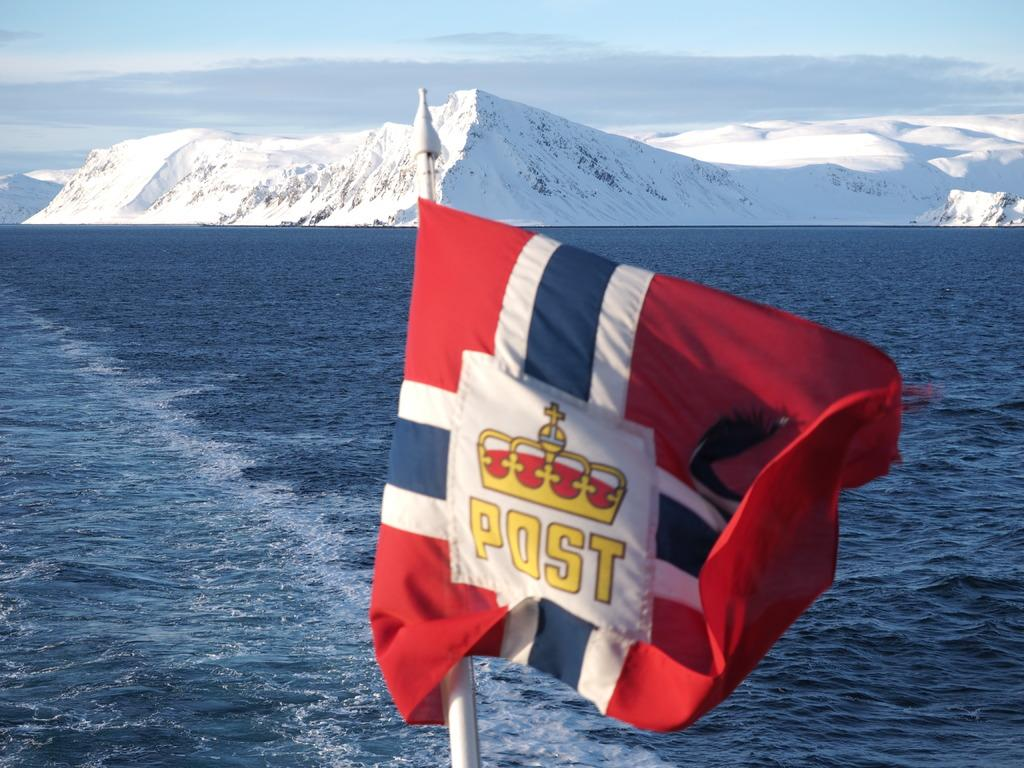What is present in the image that represents a symbol or country? There is a flag in the image. What color is the flag? The flag is red in color. What natural element can be seen in the image? There is water visible in the image. What type of geographical feature is present in the image? There are mountains with snow in the image. How many passengers are visible in the image? There are no passengers present in the image. What type of temperature can be felt in the cellar in the image? There is no cellar present in the image, so it's not possible to determine the temperature. 